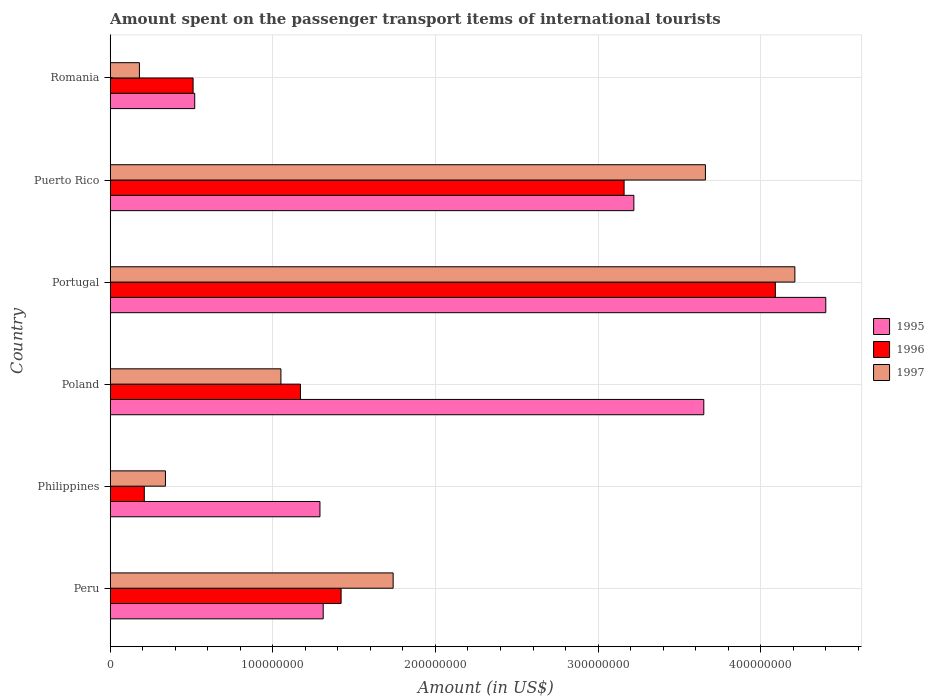How many different coloured bars are there?
Give a very brief answer. 3. How many groups of bars are there?
Make the answer very short. 6. What is the amount spent on the passenger transport items of international tourists in 1995 in Peru?
Offer a terse response. 1.31e+08. Across all countries, what is the maximum amount spent on the passenger transport items of international tourists in 1995?
Your answer should be very brief. 4.40e+08. Across all countries, what is the minimum amount spent on the passenger transport items of international tourists in 1996?
Give a very brief answer. 2.10e+07. In which country was the amount spent on the passenger transport items of international tourists in 1995 maximum?
Offer a very short reply. Portugal. What is the total amount spent on the passenger transport items of international tourists in 1995 in the graph?
Your response must be concise. 1.44e+09. What is the difference between the amount spent on the passenger transport items of international tourists in 1995 in Peru and that in Portugal?
Your response must be concise. -3.09e+08. What is the difference between the amount spent on the passenger transport items of international tourists in 1997 in Poland and the amount spent on the passenger transport items of international tourists in 1995 in Philippines?
Offer a very short reply. -2.40e+07. What is the average amount spent on the passenger transport items of international tourists in 1997 per country?
Give a very brief answer. 1.86e+08. What is the difference between the amount spent on the passenger transport items of international tourists in 1996 and amount spent on the passenger transport items of international tourists in 1995 in Philippines?
Your answer should be very brief. -1.08e+08. What is the ratio of the amount spent on the passenger transport items of international tourists in 1995 in Philippines to that in Puerto Rico?
Give a very brief answer. 0.4. Is the amount spent on the passenger transport items of international tourists in 1996 in Poland less than that in Puerto Rico?
Offer a very short reply. Yes. Is the difference between the amount spent on the passenger transport items of international tourists in 1996 in Peru and Philippines greater than the difference between the amount spent on the passenger transport items of international tourists in 1995 in Peru and Philippines?
Provide a short and direct response. Yes. What is the difference between the highest and the second highest amount spent on the passenger transport items of international tourists in 1995?
Make the answer very short. 7.50e+07. What is the difference between the highest and the lowest amount spent on the passenger transport items of international tourists in 1997?
Your answer should be very brief. 4.03e+08. Is the sum of the amount spent on the passenger transport items of international tourists in 1997 in Philippines and Puerto Rico greater than the maximum amount spent on the passenger transport items of international tourists in 1995 across all countries?
Make the answer very short. No. What does the 3rd bar from the bottom in Puerto Rico represents?
Ensure brevity in your answer.  1997. Is it the case that in every country, the sum of the amount spent on the passenger transport items of international tourists in 1997 and amount spent on the passenger transport items of international tourists in 1996 is greater than the amount spent on the passenger transport items of international tourists in 1995?
Your answer should be compact. No. How many countries are there in the graph?
Provide a short and direct response. 6. Are the values on the major ticks of X-axis written in scientific E-notation?
Offer a terse response. No. Does the graph contain grids?
Provide a succinct answer. Yes. How many legend labels are there?
Offer a very short reply. 3. What is the title of the graph?
Provide a succinct answer. Amount spent on the passenger transport items of international tourists. What is the Amount (in US$) of 1995 in Peru?
Your response must be concise. 1.31e+08. What is the Amount (in US$) of 1996 in Peru?
Your answer should be very brief. 1.42e+08. What is the Amount (in US$) of 1997 in Peru?
Ensure brevity in your answer.  1.74e+08. What is the Amount (in US$) in 1995 in Philippines?
Offer a very short reply. 1.29e+08. What is the Amount (in US$) of 1996 in Philippines?
Provide a succinct answer. 2.10e+07. What is the Amount (in US$) of 1997 in Philippines?
Offer a terse response. 3.40e+07. What is the Amount (in US$) in 1995 in Poland?
Ensure brevity in your answer.  3.65e+08. What is the Amount (in US$) in 1996 in Poland?
Your response must be concise. 1.17e+08. What is the Amount (in US$) in 1997 in Poland?
Provide a succinct answer. 1.05e+08. What is the Amount (in US$) of 1995 in Portugal?
Ensure brevity in your answer.  4.40e+08. What is the Amount (in US$) of 1996 in Portugal?
Make the answer very short. 4.09e+08. What is the Amount (in US$) in 1997 in Portugal?
Keep it short and to the point. 4.21e+08. What is the Amount (in US$) of 1995 in Puerto Rico?
Provide a short and direct response. 3.22e+08. What is the Amount (in US$) of 1996 in Puerto Rico?
Your answer should be very brief. 3.16e+08. What is the Amount (in US$) of 1997 in Puerto Rico?
Give a very brief answer. 3.66e+08. What is the Amount (in US$) of 1995 in Romania?
Your answer should be very brief. 5.20e+07. What is the Amount (in US$) of 1996 in Romania?
Your answer should be compact. 5.10e+07. What is the Amount (in US$) in 1997 in Romania?
Provide a succinct answer. 1.80e+07. Across all countries, what is the maximum Amount (in US$) in 1995?
Offer a very short reply. 4.40e+08. Across all countries, what is the maximum Amount (in US$) in 1996?
Ensure brevity in your answer.  4.09e+08. Across all countries, what is the maximum Amount (in US$) of 1997?
Provide a short and direct response. 4.21e+08. Across all countries, what is the minimum Amount (in US$) of 1995?
Give a very brief answer. 5.20e+07. Across all countries, what is the minimum Amount (in US$) of 1996?
Give a very brief answer. 2.10e+07. Across all countries, what is the minimum Amount (in US$) of 1997?
Provide a short and direct response. 1.80e+07. What is the total Amount (in US$) in 1995 in the graph?
Your answer should be compact. 1.44e+09. What is the total Amount (in US$) in 1996 in the graph?
Give a very brief answer. 1.06e+09. What is the total Amount (in US$) of 1997 in the graph?
Provide a succinct answer. 1.12e+09. What is the difference between the Amount (in US$) in 1996 in Peru and that in Philippines?
Offer a very short reply. 1.21e+08. What is the difference between the Amount (in US$) in 1997 in Peru and that in Philippines?
Provide a short and direct response. 1.40e+08. What is the difference between the Amount (in US$) in 1995 in Peru and that in Poland?
Offer a very short reply. -2.34e+08. What is the difference between the Amount (in US$) in 1996 in Peru and that in Poland?
Your response must be concise. 2.50e+07. What is the difference between the Amount (in US$) in 1997 in Peru and that in Poland?
Offer a terse response. 6.90e+07. What is the difference between the Amount (in US$) of 1995 in Peru and that in Portugal?
Your response must be concise. -3.09e+08. What is the difference between the Amount (in US$) of 1996 in Peru and that in Portugal?
Offer a very short reply. -2.67e+08. What is the difference between the Amount (in US$) in 1997 in Peru and that in Portugal?
Give a very brief answer. -2.47e+08. What is the difference between the Amount (in US$) in 1995 in Peru and that in Puerto Rico?
Your response must be concise. -1.91e+08. What is the difference between the Amount (in US$) in 1996 in Peru and that in Puerto Rico?
Make the answer very short. -1.74e+08. What is the difference between the Amount (in US$) in 1997 in Peru and that in Puerto Rico?
Your answer should be very brief. -1.92e+08. What is the difference between the Amount (in US$) of 1995 in Peru and that in Romania?
Offer a terse response. 7.90e+07. What is the difference between the Amount (in US$) in 1996 in Peru and that in Romania?
Your answer should be compact. 9.10e+07. What is the difference between the Amount (in US$) in 1997 in Peru and that in Romania?
Your response must be concise. 1.56e+08. What is the difference between the Amount (in US$) of 1995 in Philippines and that in Poland?
Make the answer very short. -2.36e+08. What is the difference between the Amount (in US$) in 1996 in Philippines and that in Poland?
Provide a succinct answer. -9.60e+07. What is the difference between the Amount (in US$) of 1997 in Philippines and that in Poland?
Give a very brief answer. -7.10e+07. What is the difference between the Amount (in US$) in 1995 in Philippines and that in Portugal?
Give a very brief answer. -3.11e+08. What is the difference between the Amount (in US$) in 1996 in Philippines and that in Portugal?
Offer a very short reply. -3.88e+08. What is the difference between the Amount (in US$) of 1997 in Philippines and that in Portugal?
Give a very brief answer. -3.87e+08. What is the difference between the Amount (in US$) in 1995 in Philippines and that in Puerto Rico?
Give a very brief answer. -1.93e+08. What is the difference between the Amount (in US$) in 1996 in Philippines and that in Puerto Rico?
Offer a very short reply. -2.95e+08. What is the difference between the Amount (in US$) of 1997 in Philippines and that in Puerto Rico?
Your answer should be compact. -3.32e+08. What is the difference between the Amount (in US$) of 1995 in Philippines and that in Romania?
Make the answer very short. 7.70e+07. What is the difference between the Amount (in US$) of 1996 in Philippines and that in Romania?
Offer a terse response. -3.00e+07. What is the difference between the Amount (in US$) in 1997 in Philippines and that in Romania?
Ensure brevity in your answer.  1.60e+07. What is the difference between the Amount (in US$) in 1995 in Poland and that in Portugal?
Offer a terse response. -7.50e+07. What is the difference between the Amount (in US$) of 1996 in Poland and that in Portugal?
Your answer should be very brief. -2.92e+08. What is the difference between the Amount (in US$) in 1997 in Poland and that in Portugal?
Offer a terse response. -3.16e+08. What is the difference between the Amount (in US$) in 1995 in Poland and that in Puerto Rico?
Your answer should be compact. 4.30e+07. What is the difference between the Amount (in US$) in 1996 in Poland and that in Puerto Rico?
Offer a very short reply. -1.99e+08. What is the difference between the Amount (in US$) in 1997 in Poland and that in Puerto Rico?
Your answer should be compact. -2.61e+08. What is the difference between the Amount (in US$) in 1995 in Poland and that in Romania?
Offer a terse response. 3.13e+08. What is the difference between the Amount (in US$) in 1996 in Poland and that in Romania?
Provide a succinct answer. 6.60e+07. What is the difference between the Amount (in US$) in 1997 in Poland and that in Romania?
Provide a short and direct response. 8.70e+07. What is the difference between the Amount (in US$) of 1995 in Portugal and that in Puerto Rico?
Your answer should be compact. 1.18e+08. What is the difference between the Amount (in US$) of 1996 in Portugal and that in Puerto Rico?
Your response must be concise. 9.30e+07. What is the difference between the Amount (in US$) of 1997 in Portugal and that in Puerto Rico?
Offer a terse response. 5.50e+07. What is the difference between the Amount (in US$) in 1995 in Portugal and that in Romania?
Your answer should be compact. 3.88e+08. What is the difference between the Amount (in US$) in 1996 in Portugal and that in Romania?
Your response must be concise. 3.58e+08. What is the difference between the Amount (in US$) in 1997 in Portugal and that in Romania?
Your answer should be very brief. 4.03e+08. What is the difference between the Amount (in US$) in 1995 in Puerto Rico and that in Romania?
Offer a terse response. 2.70e+08. What is the difference between the Amount (in US$) in 1996 in Puerto Rico and that in Romania?
Make the answer very short. 2.65e+08. What is the difference between the Amount (in US$) in 1997 in Puerto Rico and that in Romania?
Ensure brevity in your answer.  3.48e+08. What is the difference between the Amount (in US$) of 1995 in Peru and the Amount (in US$) of 1996 in Philippines?
Provide a succinct answer. 1.10e+08. What is the difference between the Amount (in US$) in 1995 in Peru and the Amount (in US$) in 1997 in Philippines?
Keep it short and to the point. 9.70e+07. What is the difference between the Amount (in US$) in 1996 in Peru and the Amount (in US$) in 1997 in Philippines?
Keep it short and to the point. 1.08e+08. What is the difference between the Amount (in US$) of 1995 in Peru and the Amount (in US$) of 1996 in Poland?
Your response must be concise. 1.40e+07. What is the difference between the Amount (in US$) in 1995 in Peru and the Amount (in US$) in 1997 in Poland?
Give a very brief answer. 2.60e+07. What is the difference between the Amount (in US$) of 1996 in Peru and the Amount (in US$) of 1997 in Poland?
Your response must be concise. 3.70e+07. What is the difference between the Amount (in US$) in 1995 in Peru and the Amount (in US$) in 1996 in Portugal?
Offer a very short reply. -2.78e+08. What is the difference between the Amount (in US$) in 1995 in Peru and the Amount (in US$) in 1997 in Portugal?
Give a very brief answer. -2.90e+08. What is the difference between the Amount (in US$) in 1996 in Peru and the Amount (in US$) in 1997 in Portugal?
Your answer should be compact. -2.79e+08. What is the difference between the Amount (in US$) in 1995 in Peru and the Amount (in US$) in 1996 in Puerto Rico?
Keep it short and to the point. -1.85e+08. What is the difference between the Amount (in US$) in 1995 in Peru and the Amount (in US$) in 1997 in Puerto Rico?
Provide a short and direct response. -2.35e+08. What is the difference between the Amount (in US$) in 1996 in Peru and the Amount (in US$) in 1997 in Puerto Rico?
Make the answer very short. -2.24e+08. What is the difference between the Amount (in US$) in 1995 in Peru and the Amount (in US$) in 1996 in Romania?
Provide a short and direct response. 8.00e+07. What is the difference between the Amount (in US$) of 1995 in Peru and the Amount (in US$) of 1997 in Romania?
Your answer should be compact. 1.13e+08. What is the difference between the Amount (in US$) in 1996 in Peru and the Amount (in US$) in 1997 in Romania?
Your answer should be compact. 1.24e+08. What is the difference between the Amount (in US$) in 1995 in Philippines and the Amount (in US$) in 1996 in Poland?
Make the answer very short. 1.20e+07. What is the difference between the Amount (in US$) of 1995 in Philippines and the Amount (in US$) of 1997 in Poland?
Provide a short and direct response. 2.40e+07. What is the difference between the Amount (in US$) in 1996 in Philippines and the Amount (in US$) in 1997 in Poland?
Ensure brevity in your answer.  -8.40e+07. What is the difference between the Amount (in US$) in 1995 in Philippines and the Amount (in US$) in 1996 in Portugal?
Offer a terse response. -2.80e+08. What is the difference between the Amount (in US$) in 1995 in Philippines and the Amount (in US$) in 1997 in Portugal?
Offer a terse response. -2.92e+08. What is the difference between the Amount (in US$) of 1996 in Philippines and the Amount (in US$) of 1997 in Portugal?
Your answer should be very brief. -4.00e+08. What is the difference between the Amount (in US$) of 1995 in Philippines and the Amount (in US$) of 1996 in Puerto Rico?
Your answer should be compact. -1.87e+08. What is the difference between the Amount (in US$) in 1995 in Philippines and the Amount (in US$) in 1997 in Puerto Rico?
Your response must be concise. -2.37e+08. What is the difference between the Amount (in US$) of 1996 in Philippines and the Amount (in US$) of 1997 in Puerto Rico?
Offer a very short reply. -3.45e+08. What is the difference between the Amount (in US$) in 1995 in Philippines and the Amount (in US$) in 1996 in Romania?
Your answer should be very brief. 7.80e+07. What is the difference between the Amount (in US$) of 1995 in Philippines and the Amount (in US$) of 1997 in Romania?
Make the answer very short. 1.11e+08. What is the difference between the Amount (in US$) of 1995 in Poland and the Amount (in US$) of 1996 in Portugal?
Offer a very short reply. -4.40e+07. What is the difference between the Amount (in US$) in 1995 in Poland and the Amount (in US$) in 1997 in Portugal?
Ensure brevity in your answer.  -5.60e+07. What is the difference between the Amount (in US$) of 1996 in Poland and the Amount (in US$) of 1997 in Portugal?
Provide a succinct answer. -3.04e+08. What is the difference between the Amount (in US$) of 1995 in Poland and the Amount (in US$) of 1996 in Puerto Rico?
Provide a short and direct response. 4.90e+07. What is the difference between the Amount (in US$) of 1996 in Poland and the Amount (in US$) of 1997 in Puerto Rico?
Make the answer very short. -2.49e+08. What is the difference between the Amount (in US$) of 1995 in Poland and the Amount (in US$) of 1996 in Romania?
Provide a short and direct response. 3.14e+08. What is the difference between the Amount (in US$) in 1995 in Poland and the Amount (in US$) in 1997 in Romania?
Make the answer very short. 3.47e+08. What is the difference between the Amount (in US$) of 1996 in Poland and the Amount (in US$) of 1997 in Romania?
Your answer should be very brief. 9.90e+07. What is the difference between the Amount (in US$) of 1995 in Portugal and the Amount (in US$) of 1996 in Puerto Rico?
Your answer should be very brief. 1.24e+08. What is the difference between the Amount (in US$) of 1995 in Portugal and the Amount (in US$) of 1997 in Puerto Rico?
Provide a succinct answer. 7.40e+07. What is the difference between the Amount (in US$) of 1996 in Portugal and the Amount (in US$) of 1997 in Puerto Rico?
Provide a short and direct response. 4.30e+07. What is the difference between the Amount (in US$) in 1995 in Portugal and the Amount (in US$) in 1996 in Romania?
Keep it short and to the point. 3.89e+08. What is the difference between the Amount (in US$) in 1995 in Portugal and the Amount (in US$) in 1997 in Romania?
Your response must be concise. 4.22e+08. What is the difference between the Amount (in US$) in 1996 in Portugal and the Amount (in US$) in 1997 in Romania?
Ensure brevity in your answer.  3.91e+08. What is the difference between the Amount (in US$) of 1995 in Puerto Rico and the Amount (in US$) of 1996 in Romania?
Your answer should be compact. 2.71e+08. What is the difference between the Amount (in US$) in 1995 in Puerto Rico and the Amount (in US$) in 1997 in Romania?
Make the answer very short. 3.04e+08. What is the difference between the Amount (in US$) in 1996 in Puerto Rico and the Amount (in US$) in 1997 in Romania?
Ensure brevity in your answer.  2.98e+08. What is the average Amount (in US$) of 1995 per country?
Ensure brevity in your answer.  2.40e+08. What is the average Amount (in US$) in 1996 per country?
Make the answer very short. 1.76e+08. What is the average Amount (in US$) of 1997 per country?
Offer a very short reply. 1.86e+08. What is the difference between the Amount (in US$) in 1995 and Amount (in US$) in 1996 in Peru?
Give a very brief answer. -1.10e+07. What is the difference between the Amount (in US$) of 1995 and Amount (in US$) of 1997 in Peru?
Offer a terse response. -4.30e+07. What is the difference between the Amount (in US$) in 1996 and Amount (in US$) in 1997 in Peru?
Your answer should be very brief. -3.20e+07. What is the difference between the Amount (in US$) in 1995 and Amount (in US$) in 1996 in Philippines?
Offer a very short reply. 1.08e+08. What is the difference between the Amount (in US$) of 1995 and Amount (in US$) of 1997 in Philippines?
Provide a succinct answer. 9.50e+07. What is the difference between the Amount (in US$) in 1996 and Amount (in US$) in 1997 in Philippines?
Keep it short and to the point. -1.30e+07. What is the difference between the Amount (in US$) of 1995 and Amount (in US$) of 1996 in Poland?
Your answer should be very brief. 2.48e+08. What is the difference between the Amount (in US$) in 1995 and Amount (in US$) in 1997 in Poland?
Make the answer very short. 2.60e+08. What is the difference between the Amount (in US$) in 1996 and Amount (in US$) in 1997 in Poland?
Offer a terse response. 1.20e+07. What is the difference between the Amount (in US$) of 1995 and Amount (in US$) of 1996 in Portugal?
Your answer should be compact. 3.10e+07. What is the difference between the Amount (in US$) in 1995 and Amount (in US$) in 1997 in Portugal?
Your answer should be very brief. 1.90e+07. What is the difference between the Amount (in US$) of 1996 and Amount (in US$) of 1997 in Portugal?
Provide a short and direct response. -1.20e+07. What is the difference between the Amount (in US$) in 1995 and Amount (in US$) in 1996 in Puerto Rico?
Ensure brevity in your answer.  6.00e+06. What is the difference between the Amount (in US$) in 1995 and Amount (in US$) in 1997 in Puerto Rico?
Offer a very short reply. -4.40e+07. What is the difference between the Amount (in US$) of 1996 and Amount (in US$) of 1997 in Puerto Rico?
Your answer should be very brief. -5.00e+07. What is the difference between the Amount (in US$) of 1995 and Amount (in US$) of 1997 in Romania?
Make the answer very short. 3.40e+07. What is the difference between the Amount (in US$) of 1996 and Amount (in US$) of 1997 in Romania?
Ensure brevity in your answer.  3.30e+07. What is the ratio of the Amount (in US$) of 1995 in Peru to that in Philippines?
Provide a short and direct response. 1.02. What is the ratio of the Amount (in US$) in 1996 in Peru to that in Philippines?
Your answer should be very brief. 6.76. What is the ratio of the Amount (in US$) in 1997 in Peru to that in Philippines?
Give a very brief answer. 5.12. What is the ratio of the Amount (in US$) in 1995 in Peru to that in Poland?
Your answer should be very brief. 0.36. What is the ratio of the Amount (in US$) of 1996 in Peru to that in Poland?
Your response must be concise. 1.21. What is the ratio of the Amount (in US$) of 1997 in Peru to that in Poland?
Keep it short and to the point. 1.66. What is the ratio of the Amount (in US$) in 1995 in Peru to that in Portugal?
Your answer should be compact. 0.3. What is the ratio of the Amount (in US$) in 1996 in Peru to that in Portugal?
Your answer should be compact. 0.35. What is the ratio of the Amount (in US$) in 1997 in Peru to that in Portugal?
Give a very brief answer. 0.41. What is the ratio of the Amount (in US$) in 1995 in Peru to that in Puerto Rico?
Your response must be concise. 0.41. What is the ratio of the Amount (in US$) in 1996 in Peru to that in Puerto Rico?
Give a very brief answer. 0.45. What is the ratio of the Amount (in US$) in 1997 in Peru to that in Puerto Rico?
Offer a terse response. 0.48. What is the ratio of the Amount (in US$) in 1995 in Peru to that in Romania?
Provide a succinct answer. 2.52. What is the ratio of the Amount (in US$) of 1996 in Peru to that in Romania?
Provide a succinct answer. 2.78. What is the ratio of the Amount (in US$) of 1997 in Peru to that in Romania?
Keep it short and to the point. 9.67. What is the ratio of the Amount (in US$) of 1995 in Philippines to that in Poland?
Offer a terse response. 0.35. What is the ratio of the Amount (in US$) in 1996 in Philippines to that in Poland?
Your answer should be very brief. 0.18. What is the ratio of the Amount (in US$) of 1997 in Philippines to that in Poland?
Keep it short and to the point. 0.32. What is the ratio of the Amount (in US$) of 1995 in Philippines to that in Portugal?
Offer a terse response. 0.29. What is the ratio of the Amount (in US$) in 1996 in Philippines to that in Portugal?
Your answer should be compact. 0.05. What is the ratio of the Amount (in US$) in 1997 in Philippines to that in Portugal?
Offer a very short reply. 0.08. What is the ratio of the Amount (in US$) in 1995 in Philippines to that in Puerto Rico?
Provide a succinct answer. 0.4. What is the ratio of the Amount (in US$) in 1996 in Philippines to that in Puerto Rico?
Provide a succinct answer. 0.07. What is the ratio of the Amount (in US$) of 1997 in Philippines to that in Puerto Rico?
Make the answer very short. 0.09. What is the ratio of the Amount (in US$) in 1995 in Philippines to that in Romania?
Your response must be concise. 2.48. What is the ratio of the Amount (in US$) of 1996 in Philippines to that in Romania?
Provide a short and direct response. 0.41. What is the ratio of the Amount (in US$) of 1997 in Philippines to that in Romania?
Make the answer very short. 1.89. What is the ratio of the Amount (in US$) in 1995 in Poland to that in Portugal?
Offer a terse response. 0.83. What is the ratio of the Amount (in US$) of 1996 in Poland to that in Portugal?
Your answer should be very brief. 0.29. What is the ratio of the Amount (in US$) in 1997 in Poland to that in Portugal?
Provide a succinct answer. 0.25. What is the ratio of the Amount (in US$) in 1995 in Poland to that in Puerto Rico?
Offer a terse response. 1.13. What is the ratio of the Amount (in US$) in 1996 in Poland to that in Puerto Rico?
Give a very brief answer. 0.37. What is the ratio of the Amount (in US$) in 1997 in Poland to that in Puerto Rico?
Your response must be concise. 0.29. What is the ratio of the Amount (in US$) of 1995 in Poland to that in Romania?
Make the answer very short. 7.02. What is the ratio of the Amount (in US$) in 1996 in Poland to that in Romania?
Ensure brevity in your answer.  2.29. What is the ratio of the Amount (in US$) in 1997 in Poland to that in Romania?
Your answer should be very brief. 5.83. What is the ratio of the Amount (in US$) of 1995 in Portugal to that in Puerto Rico?
Offer a terse response. 1.37. What is the ratio of the Amount (in US$) in 1996 in Portugal to that in Puerto Rico?
Make the answer very short. 1.29. What is the ratio of the Amount (in US$) in 1997 in Portugal to that in Puerto Rico?
Make the answer very short. 1.15. What is the ratio of the Amount (in US$) in 1995 in Portugal to that in Romania?
Give a very brief answer. 8.46. What is the ratio of the Amount (in US$) of 1996 in Portugal to that in Romania?
Your response must be concise. 8.02. What is the ratio of the Amount (in US$) of 1997 in Portugal to that in Romania?
Ensure brevity in your answer.  23.39. What is the ratio of the Amount (in US$) of 1995 in Puerto Rico to that in Romania?
Make the answer very short. 6.19. What is the ratio of the Amount (in US$) in 1996 in Puerto Rico to that in Romania?
Your answer should be compact. 6.2. What is the ratio of the Amount (in US$) of 1997 in Puerto Rico to that in Romania?
Your response must be concise. 20.33. What is the difference between the highest and the second highest Amount (in US$) in 1995?
Make the answer very short. 7.50e+07. What is the difference between the highest and the second highest Amount (in US$) of 1996?
Your response must be concise. 9.30e+07. What is the difference between the highest and the second highest Amount (in US$) of 1997?
Ensure brevity in your answer.  5.50e+07. What is the difference between the highest and the lowest Amount (in US$) of 1995?
Provide a succinct answer. 3.88e+08. What is the difference between the highest and the lowest Amount (in US$) of 1996?
Your answer should be compact. 3.88e+08. What is the difference between the highest and the lowest Amount (in US$) in 1997?
Provide a succinct answer. 4.03e+08. 